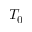<formula> <loc_0><loc_0><loc_500><loc_500>T _ { 0 }</formula> 